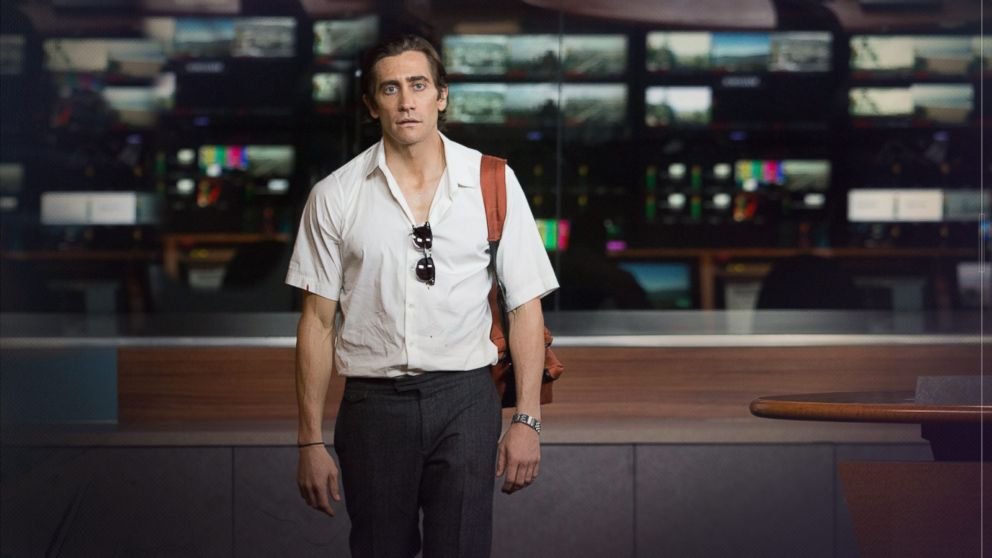How does this setting contribute to the atmosphere or tone of the movie? The background filled with screens and electronics bathed in artificial light creates a high-tech yet sterile atmosphere. This setting underscores the movie's themes of surveillance and the voyeuristic nature of modern news media, where visuals are constantly captured and monitored, mirroring the protagonist's own moral and ethical journey in the world of night-time journalism. 